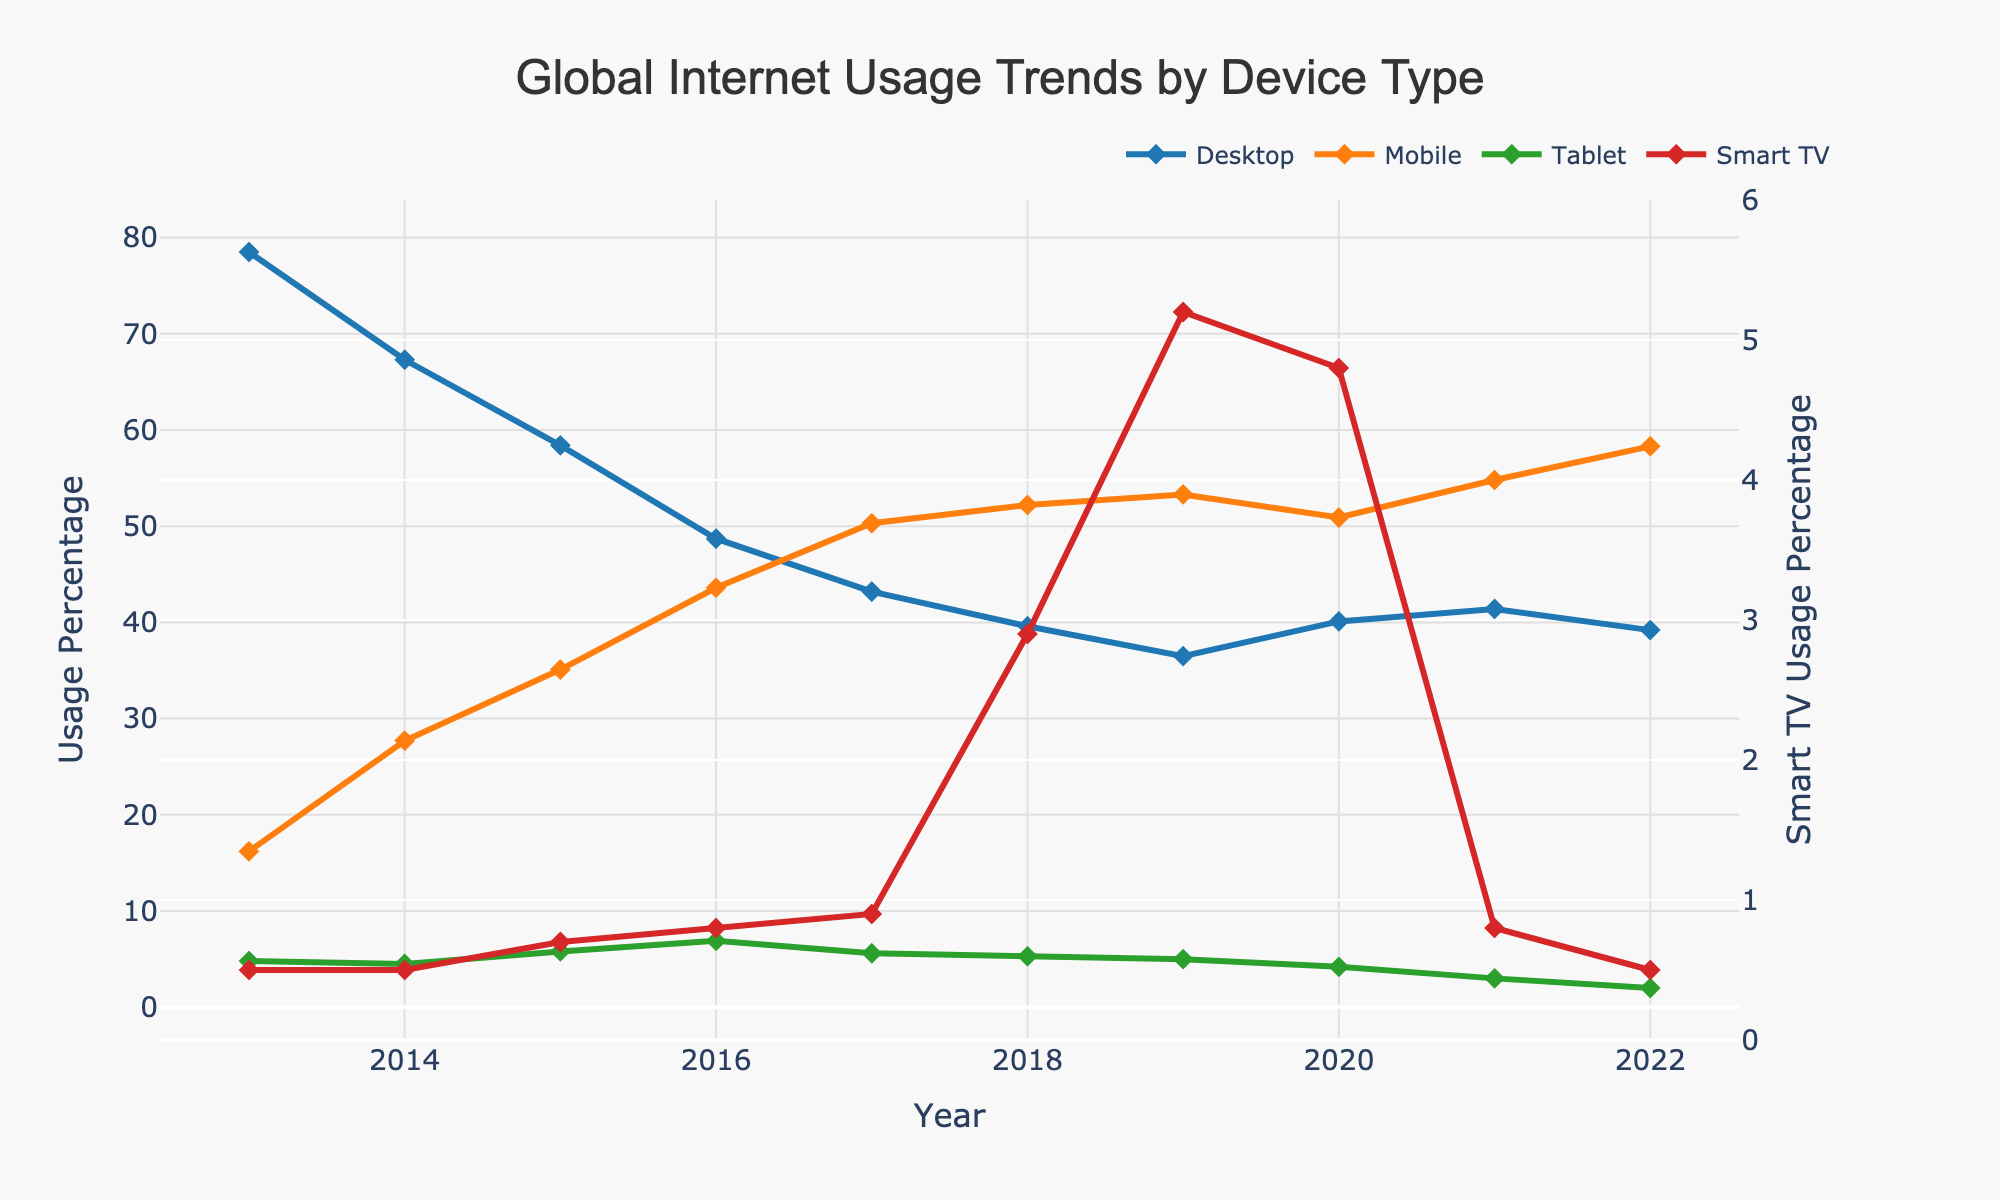What device type had the highest usage percentage in 2022? In 2022, Mobile had the highest usage percentage among all the device types shown in the chart. This can be seen by looking at the height of the Mobile line, which reached 58.3%
Answer: Mobile How did the Desktop usage percentage change from 2013 to 2022? In 2013, Desktop usage was at 78.5%, and by 2022, it decreased to 39.2%. The difference is 78.5% - 39.2% = 39.3%. This shows a decrease in Desktop usage over the decade.
Answer: It decreased by 39.3% Is the trend in Smart TV usage increasing or decreasing over the years? Observing the trend for Smart TV usage from 2013 to 2022, it started at 0.5% in 2013 and, though it had some fluctuations, it has a minor overall increase, ending at 0.5% in 2022, thus showing no significant increase or decrease over the long term.
Answer: No significant change Which year had the highest percentage of Tablet usage? By analyzing the points and heights of the Tablet line on the chart, it can be noted that the year 2016 had the highest Tablet usage at 6.9%.
Answer: 2016 Compare the Mobile and Desktop usage percentages in 2015. Looking at the chart, the Desktop usage in 2015 was 58.4%, while Mobile usage was 35.1%. Desktop usage was higher than Mobile by 58.4% - 35.1% = 23.3% in that year.
Answer: Desktop usage was higher by 23.3% What is the average percentage usage of Mobile from 2013 to 2022? Sum up the Mobile usage percentages from each year (16.2 + 27.7 + 35.1 + 43.6 + 50.3 + 52.2 + 53.3 + 50.9 + 54.8 + 58.3) and then divide by the number of years (10). The calculation is (442.4) / 10 = 44.24%.
Answer: 44.24% Which year saw the lowest Desktop usage percentage and what was it? By inspecting the chart and noting the points along the Desktop line, it is observed that 2022 had the lowest Desktop usage with a percentage of 39.2%.
Answer: 2022, 39.2% How did the percentage of Smart TV usage in 2019 compare to that in 2013? Smart TV usage in 2013 was 0.5%, and in 2019 it was 5.2%. The change is 5.2% - 0.5% = 4.7%, indicating an increase in Smart TV usage over this period.
Answer: Increased by 4.7% In which year did Mobile usage surpass Desktop usage, and by how much? By observing the crossing point of the Mobile and Desktop lines, Mobile usage surpassed Desktop in 2016, with Mobile at 43.6% and Desktop at 48.7%. The difference is 43.6% - 48.7% = -5.1%, indicating Desktop was still slightly higher, so the actual surpass happens in 2017 where Mobile at 50.3% and Desktop at 43.2%. Thus, Mobile usage surpassed Desktop by 50.3% - 43.2% = 7.1% in 2017.
Answer: 2017, by 7.1% What was the combined usage percentage of Desktop and Mobile in 2020? Adding the Desktop and Mobile percentages for 2020 gives 40.1% + 50.9% = 91%.
Answer: 91% 